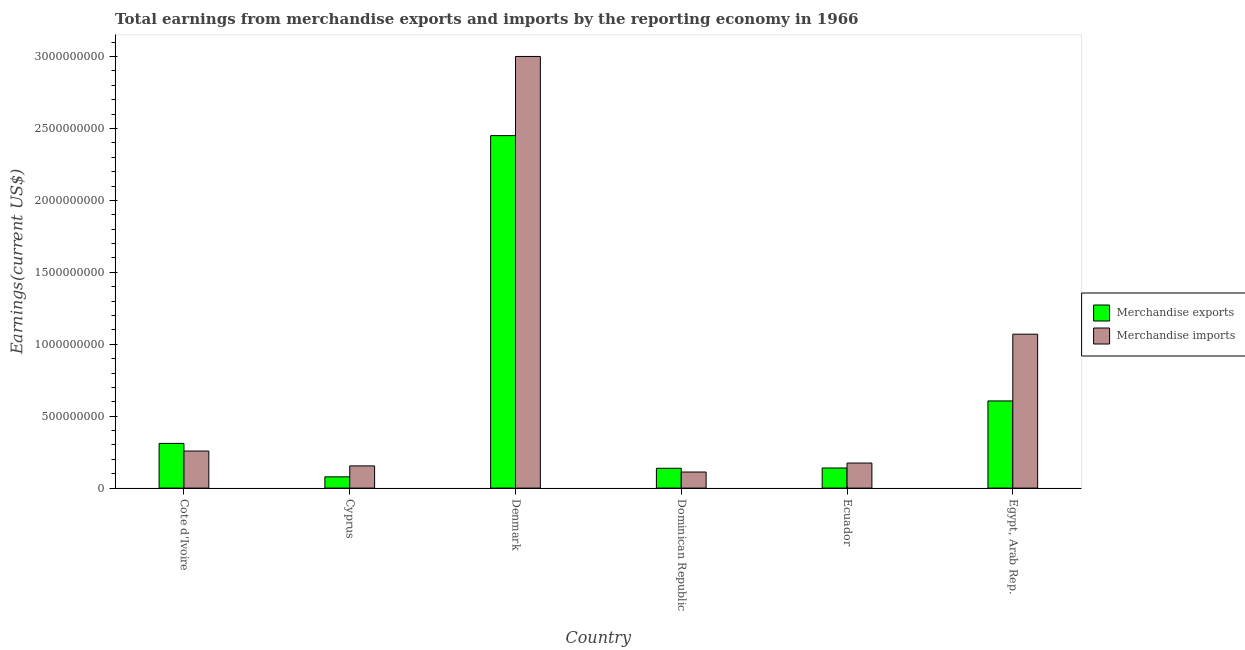How many groups of bars are there?
Provide a short and direct response. 6. How many bars are there on the 1st tick from the left?
Your response must be concise. 2. What is the label of the 1st group of bars from the left?
Keep it short and to the point. Cote d'Ivoire. What is the earnings from merchandise imports in Cote d'Ivoire?
Keep it short and to the point. 2.58e+08. Across all countries, what is the maximum earnings from merchandise imports?
Make the answer very short. 3.00e+09. Across all countries, what is the minimum earnings from merchandise imports?
Offer a very short reply. 1.12e+08. In which country was the earnings from merchandise exports maximum?
Keep it short and to the point. Denmark. In which country was the earnings from merchandise exports minimum?
Provide a short and direct response. Cyprus. What is the total earnings from merchandise exports in the graph?
Make the answer very short. 3.72e+09. What is the difference between the earnings from merchandise imports in Dominican Republic and that in Egypt, Arab Rep.?
Provide a short and direct response. -9.58e+08. What is the difference between the earnings from merchandise imports in Cyprus and the earnings from merchandise exports in Dominican Republic?
Ensure brevity in your answer.  1.65e+07. What is the average earnings from merchandise imports per country?
Provide a short and direct response. 7.95e+08. What is the difference between the earnings from merchandise exports and earnings from merchandise imports in Dominican Republic?
Your answer should be compact. 2.60e+07. What is the ratio of the earnings from merchandise imports in Denmark to that in Dominican Republic?
Offer a very short reply. 26.86. Is the earnings from merchandise exports in Cote d'Ivoire less than that in Cyprus?
Provide a succinct answer. No. Is the difference between the earnings from merchandise imports in Denmark and Egypt, Arab Rep. greater than the difference between the earnings from merchandise exports in Denmark and Egypt, Arab Rep.?
Give a very brief answer. Yes. What is the difference between the highest and the second highest earnings from merchandise imports?
Make the answer very short. 1.93e+09. What is the difference between the highest and the lowest earnings from merchandise exports?
Your answer should be compact. 2.37e+09. In how many countries, is the earnings from merchandise exports greater than the average earnings from merchandise exports taken over all countries?
Offer a terse response. 1. What does the 2nd bar from the right in Cote d'Ivoire represents?
Give a very brief answer. Merchandise exports. How many bars are there?
Your response must be concise. 12. Are all the bars in the graph horizontal?
Your answer should be compact. No. Are the values on the major ticks of Y-axis written in scientific E-notation?
Keep it short and to the point. No. Where does the legend appear in the graph?
Provide a short and direct response. Center right. How many legend labels are there?
Make the answer very short. 2. What is the title of the graph?
Keep it short and to the point. Total earnings from merchandise exports and imports by the reporting economy in 1966. Does "Tetanus" appear as one of the legend labels in the graph?
Offer a very short reply. No. What is the label or title of the Y-axis?
Your answer should be compact. Earnings(current US$). What is the Earnings(current US$) of Merchandise exports in Cote d'Ivoire?
Your answer should be very brief. 3.11e+08. What is the Earnings(current US$) in Merchandise imports in Cote d'Ivoire?
Offer a terse response. 2.58e+08. What is the Earnings(current US$) of Merchandise exports in Cyprus?
Your answer should be very brief. 7.82e+07. What is the Earnings(current US$) of Merchandise imports in Cyprus?
Provide a succinct answer. 1.54e+08. What is the Earnings(current US$) of Merchandise exports in Denmark?
Your answer should be compact. 2.45e+09. What is the Earnings(current US$) of Merchandise imports in Denmark?
Your answer should be compact. 3.00e+09. What is the Earnings(current US$) in Merchandise exports in Dominican Republic?
Your answer should be compact. 1.38e+08. What is the Earnings(current US$) of Merchandise imports in Dominican Republic?
Keep it short and to the point. 1.12e+08. What is the Earnings(current US$) of Merchandise exports in Ecuador?
Your response must be concise. 1.40e+08. What is the Earnings(current US$) of Merchandise imports in Ecuador?
Your answer should be compact. 1.74e+08. What is the Earnings(current US$) of Merchandise exports in Egypt, Arab Rep.?
Your answer should be very brief. 6.06e+08. What is the Earnings(current US$) of Merchandise imports in Egypt, Arab Rep.?
Your response must be concise. 1.07e+09. Across all countries, what is the maximum Earnings(current US$) of Merchandise exports?
Offer a terse response. 2.45e+09. Across all countries, what is the maximum Earnings(current US$) of Merchandise imports?
Keep it short and to the point. 3.00e+09. Across all countries, what is the minimum Earnings(current US$) in Merchandise exports?
Make the answer very short. 7.82e+07. Across all countries, what is the minimum Earnings(current US$) of Merchandise imports?
Give a very brief answer. 1.12e+08. What is the total Earnings(current US$) of Merchandise exports in the graph?
Provide a succinct answer. 3.72e+09. What is the total Earnings(current US$) of Merchandise imports in the graph?
Offer a terse response. 4.77e+09. What is the difference between the Earnings(current US$) of Merchandise exports in Cote d'Ivoire and that in Cyprus?
Ensure brevity in your answer.  2.32e+08. What is the difference between the Earnings(current US$) in Merchandise imports in Cote d'Ivoire and that in Cyprus?
Give a very brief answer. 1.03e+08. What is the difference between the Earnings(current US$) in Merchandise exports in Cote d'Ivoire and that in Denmark?
Your response must be concise. -2.14e+09. What is the difference between the Earnings(current US$) of Merchandise imports in Cote d'Ivoire and that in Denmark?
Offer a very short reply. -2.74e+09. What is the difference between the Earnings(current US$) in Merchandise exports in Cote d'Ivoire and that in Dominican Republic?
Ensure brevity in your answer.  1.73e+08. What is the difference between the Earnings(current US$) in Merchandise imports in Cote d'Ivoire and that in Dominican Republic?
Provide a short and direct response. 1.46e+08. What is the difference between the Earnings(current US$) of Merchandise exports in Cote d'Ivoire and that in Ecuador?
Your answer should be compact. 1.71e+08. What is the difference between the Earnings(current US$) of Merchandise imports in Cote d'Ivoire and that in Ecuador?
Offer a terse response. 8.35e+07. What is the difference between the Earnings(current US$) of Merchandise exports in Cote d'Ivoire and that in Egypt, Arab Rep.?
Your response must be concise. -2.95e+08. What is the difference between the Earnings(current US$) of Merchandise imports in Cote d'Ivoire and that in Egypt, Arab Rep.?
Offer a terse response. -8.12e+08. What is the difference between the Earnings(current US$) in Merchandise exports in Cyprus and that in Denmark?
Your response must be concise. -2.37e+09. What is the difference between the Earnings(current US$) in Merchandise imports in Cyprus and that in Denmark?
Offer a terse response. -2.85e+09. What is the difference between the Earnings(current US$) in Merchandise exports in Cyprus and that in Dominican Republic?
Your response must be concise. -5.96e+07. What is the difference between the Earnings(current US$) of Merchandise imports in Cyprus and that in Dominican Republic?
Your answer should be very brief. 4.26e+07. What is the difference between the Earnings(current US$) in Merchandise exports in Cyprus and that in Ecuador?
Your answer should be very brief. -6.15e+07. What is the difference between the Earnings(current US$) of Merchandise imports in Cyprus and that in Ecuador?
Ensure brevity in your answer.  -1.98e+07. What is the difference between the Earnings(current US$) in Merchandise exports in Cyprus and that in Egypt, Arab Rep.?
Keep it short and to the point. -5.28e+08. What is the difference between the Earnings(current US$) in Merchandise imports in Cyprus and that in Egypt, Arab Rep.?
Make the answer very short. -9.16e+08. What is the difference between the Earnings(current US$) of Merchandise exports in Denmark and that in Dominican Republic?
Provide a succinct answer. 2.31e+09. What is the difference between the Earnings(current US$) of Merchandise imports in Denmark and that in Dominican Republic?
Your answer should be very brief. 2.89e+09. What is the difference between the Earnings(current US$) of Merchandise exports in Denmark and that in Ecuador?
Your response must be concise. 2.31e+09. What is the difference between the Earnings(current US$) in Merchandise imports in Denmark and that in Ecuador?
Your answer should be very brief. 2.83e+09. What is the difference between the Earnings(current US$) of Merchandise exports in Denmark and that in Egypt, Arab Rep.?
Make the answer very short. 1.84e+09. What is the difference between the Earnings(current US$) of Merchandise imports in Denmark and that in Egypt, Arab Rep.?
Ensure brevity in your answer.  1.93e+09. What is the difference between the Earnings(current US$) in Merchandise exports in Dominican Republic and that in Ecuador?
Offer a very short reply. -1.96e+06. What is the difference between the Earnings(current US$) of Merchandise imports in Dominican Republic and that in Ecuador?
Keep it short and to the point. -6.24e+07. What is the difference between the Earnings(current US$) of Merchandise exports in Dominican Republic and that in Egypt, Arab Rep.?
Offer a terse response. -4.68e+08. What is the difference between the Earnings(current US$) in Merchandise imports in Dominican Republic and that in Egypt, Arab Rep.?
Give a very brief answer. -9.58e+08. What is the difference between the Earnings(current US$) in Merchandise exports in Ecuador and that in Egypt, Arab Rep.?
Give a very brief answer. -4.66e+08. What is the difference between the Earnings(current US$) in Merchandise imports in Ecuador and that in Egypt, Arab Rep.?
Ensure brevity in your answer.  -8.96e+08. What is the difference between the Earnings(current US$) of Merchandise exports in Cote d'Ivoire and the Earnings(current US$) of Merchandise imports in Cyprus?
Provide a short and direct response. 1.56e+08. What is the difference between the Earnings(current US$) of Merchandise exports in Cote d'Ivoire and the Earnings(current US$) of Merchandise imports in Denmark?
Offer a terse response. -2.69e+09. What is the difference between the Earnings(current US$) in Merchandise exports in Cote d'Ivoire and the Earnings(current US$) in Merchandise imports in Dominican Republic?
Offer a terse response. 1.99e+08. What is the difference between the Earnings(current US$) in Merchandise exports in Cote d'Ivoire and the Earnings(current US$) in Merchandise imports in Ecuador?
Keep it short and to the point. 1.37e+08. What is the difference between the Earnings(current US$) of Merchandise exports in Cote d'Ivoire and the Earnings(current US$) of Merchandise imports in Egypt, Arab Rep.?
Your answer should be very brief. -7.59e+08. What is the difference between the Earnings(current US$) of Merchandise exports in Cyprus and the Earnings(current US$) of Merchandise imports in Denmark?
Give a very brief answer. -2.92e+09. What is the difference between the Earnings(current US$) in Merchandise exports in Cyprus and the Earnings(current US$) in Merchandise imports in Dominican Republic?
Offer a very short reply. -3.35e+07. What is the difference between the Earnings(current US$) in Merchandise exports in Cyprus and the Earnings(current US$) in Merchandise imports in Ecuador?
Ensure brevity in your answer.  -9.59e+07. What is the difference between the Earnings(current US$) in Merchandise exports in Cyprus and the Earnings(current US$) in Merchandise imports in Egypt, Arab Rep.?
Offer a very short reply. -9.92e+08. What is the difference between the Earnings(current US$) of Merchandise exports in Denmark and the Earnings(current US$) of Merchandise imports in Dominican Republic?
Your response must be concise. 2.34e+09. What is the difference between the Earnings(current US$) in Merchandise exports in Denmark and the Earnings(current US$) in Merchandise imports in Ecuador?
Give a very brief answer. 2.28e+09. What is the difference between the Earnings(current US$) in Merchandise exports in Denmark and the Earnings(current US$) in Merchandise imports in Egypt, Arab Rep.?
Make the answer very short. 1.38e+09. What is the difference between the Earnings(current US$) of Merchandise exports in Dominican Republic and the Earnings(current US$) of Merchandise imports in Ecuador?
Keep it short and to the point. -3.64e+07. What is the difference between the Earnings(current US$) in Merchandise exports in Dominican Republic and the Earnings(current US$) in Merchandise imports in Egypt, Arab Rep.?
Offer a terse response. -9.32e+08. What is the difference between the Earnings(current US$) in Merchandise exports in Ecuador and the Earnings(current US$) in Merchandise imports in Egypt, Arab Rep.?
Keep it short and to the point. -9.30e+08. What is the average Earnings(current US$) in Merchandise exports per country?
Keep it short and to the point. 6.20e+08. What is the average Earnings(current US$) in Merchandise imports per country?
Make the answer very short. 7.95e+08. What is the difference between the Earnings(current US$) of Merchandise exports and Earnings(current US$) of Merchandise imports in Cote d'Ivoire?
Your answer should be compact. 5.31e+07. What is the difference between the Earnings(current US$) in Merchandise exports and Earnings(current US$) in Merchandise imports in Cyprus?
Offer a terse response. -7.61e+07. What is the difference between the Earnings(current US$) of Merchandise exports and Earnings(current US$) of Merchandise imports in Denmark?
Ensure brevity in your answer.  -5.50e+08. What is the difference between the Earnings(current US$) of Merchandise exports and Earnings(current US$) of Merchandise imports in Dominican Republic?
Your response must be concise. 2.60e+07. What is the difference between the Earnings(current US$) in Merchandise exports and Earnings(current US$) in Merchandise imports in Ecuador?
Your answer should be compact. -3.44e+07. What is the difference between the Earnings(current US$) in Merchandise exports and Earnings(current US$) in Merchandise imports in Egypt, Arab Rep.?
Offer a terse response. -4.64e+08. What is the ratio of the Earnings(current US$) of Merchandise exports in Cote d'Ivoire to that in Cyprus?
Provide a succinct answer. 3.97. What is the ratio of the Earnings(current US$) of Merchandise imports in Cote d'Ivoire to that in Cyprus?
Provide a short and direct response. 1.67. What is the ratio of the Earnings(current US$) of Merchandise exports in Cote d'Ivoire to that in Denmark?
Keep it short and to the point. 0.13. What is the ratio of the Earnings(current US$) of Merchandise imports in Cote d'Ivoire to that in Denmark?
Your response must be concise. 0.09. What is the ratio of the Earnings(current US$) of Merchandise exports in Cote d'Ivoire to that in Dominican Republic?
Give a very brief answer. 2.26. What is the ratio of the Earnings(current US$) in Merchandise imports in Cote d'Ivoire to that in Dominican Republic?
Your answer should be compact. 2.31. What is the ratio of the Earnings(current US$) of Merchandise exports in Cote d'Ivoire to that in Ecuador?
Your answer should be compact. 2.22. What is the ratio of the Earnings(current US$) in Merchandise imports in Cote d'Ivoire to that in Ecuador?
Keep it short and to the point. 1.48. What is the ratio of the Earnings(current US$) of Merchandise exports in Cote d'Ivoire to that in Egypt, Arab Rep.?
Ensure brevity in your answer.  0.51. What is the ratio of the Earnings(current US$) of Merchandise imports in Cote d'Ivoire to that in Egypt, Arab Rep.?
Provide a short and direct response. 0.24. What is the ratio of the Earnings(current US$) of Merchandise exports in Cyprus to that in Denmark?
Provide a succinct answer. 0.03. What is the ratio of the Earnings(current US$) in Merchandise imports in Cyprus to that in Denmark?
Give a very brief answer. 0.05. What is the ratio of the Earnings(current US$) of Merchandise exports in Cyprus to that in Dominican Republic?
Your answer should be very brief. 0.57. What is the ratio of the Earnings(current US$) of Merchandise imports in Cyprus to that in Dominican Republic?
Ensure brevity in your answer.  1.38. What is the ratio of the Earnings(current US$) in Merchandise exports in Cyprus to that in Ecuador?
Provide a short and direct response. 0.56. What is the ratio of the Earnings(current US$) in Merchandise imports in Cyprus to that in Ecuador?
Offer a very short reply. 0.89. What is the ratio of the Earnings(current US$) of Merchandise exports in Cyprus to that in Egypt, Arab Rep.?
Ensure brevity in your answer.  0.13. What is the ratio of the Earnings(current US$) of Merchandise imports in Cyprus to that in Egypt, Arab Rep.?
Ensure brevity in your answer.  0.14. What is the ratio of the Earnings(current US$) of Merchandise exports in Denmark to that in Dominican Republic?
Make the answer very short. 17.79. What is the ratio of the Earnings(current US$) of Merchandise imports in Denmark to that in Dominican Republic?
Your answer should be compact. 26.86. What is the ratio of the Earnings(current US$) in Merchandise exports in Denmark to that in Ecuador?
Provide a succinct answer. 17.54. What is the ratio of the Earnings(current US$) in Merchandise imports in Denmark to that in Ecuador?
Offer a terse response. 17.23. What is the ratio of the Earnings(current US$) in Merchandise exports in Denmark to that in Egypt, Arab Rep.?
Your answer should be compact. 4.04. What is the ratio of the Earnings(current US$) in Merchandise imports in Denmark to that in Egypt, Arab Rep.?
Make the answer very short. 2.8. What is the ratio of the Earnings(current US$) of Merchandise imports in Dominican Republic to that in Ecuador?
Your answer should be very brief. 0.64. What is the ratio of the Earnings(current US$) in Merchandise exports in Dominican Republic to that in Egypt, Arab Rep.?
Provide a succinct answer. 0.23. What is the ratio of the Earnings(current US$) in Merchandise imports in Dominican Republic to that in Egypt, Arab Rep.?
Make the answer very short. 0.1. What is the ratio of the Earnings(current US$) in Merchandise exports in Ecuador to that in Egypt, Arab Rep.?
Ensure brevity in your answer.  0.23. What is the ratio of the Earnings(current US$) of Merchandise imports in Ecuador to that in Egypt, Arab Rep.?
Offer a very short reply. 0.16. What is the difference between the highest and the second highest Earnings(current US$) of Merchandise exports?
Your answer should be compact. 1.84e+09. What is the difference between the highest and the second highest Earnings(current US$) of Merchandise imports?
Your response must be concise. 1.93e+09. What is the difference between the highest and the lowest Earnings(current US$) of Merchandise exports?
Provide a succinct answer. 2.37e+09. What is the difference between the highest and the lowest Earnings(current US$) in Merchandise imports?
Your answer should be compact. 2.89e+09. 